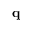Convert formula to latex. <formula><loc_0><loc_0><loc_500><loc_500>{ q }</formula> 